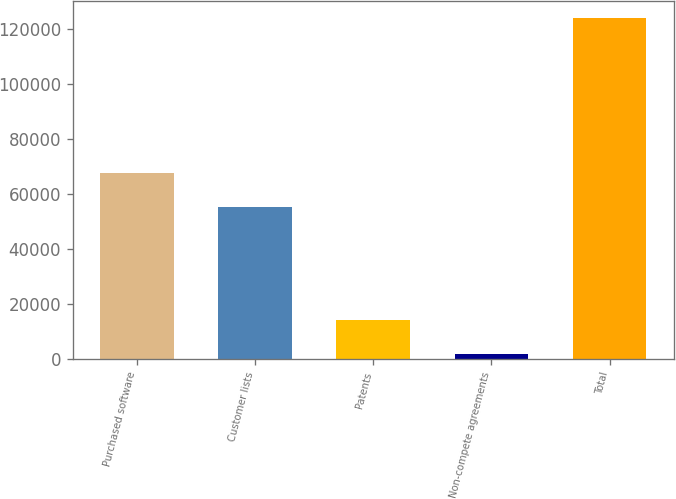<chart> <loc_0><loc_0><loc_500><loc_500><bar_chart><fcel>Purchased software<fcel>Customer lists<fcel>Patents<fcel>Non-compete agreements<fcel>Total<nl><fcel>67582.5<fcel>55384<fcel>14022.5<fcel>1824<fcel>123809<nl></chart> 